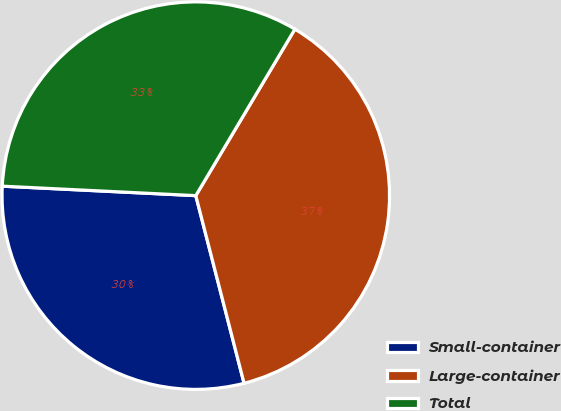Convert chart to OTSL. <chart><loc_0><loc_0><loc_500><loc_500><pie_chart><fcel>Small-container<fcel>Large-container<fcel>Total<nl><fcel>29.79%<fcel>37.45%<fcel>32.77%<nl></chart> 